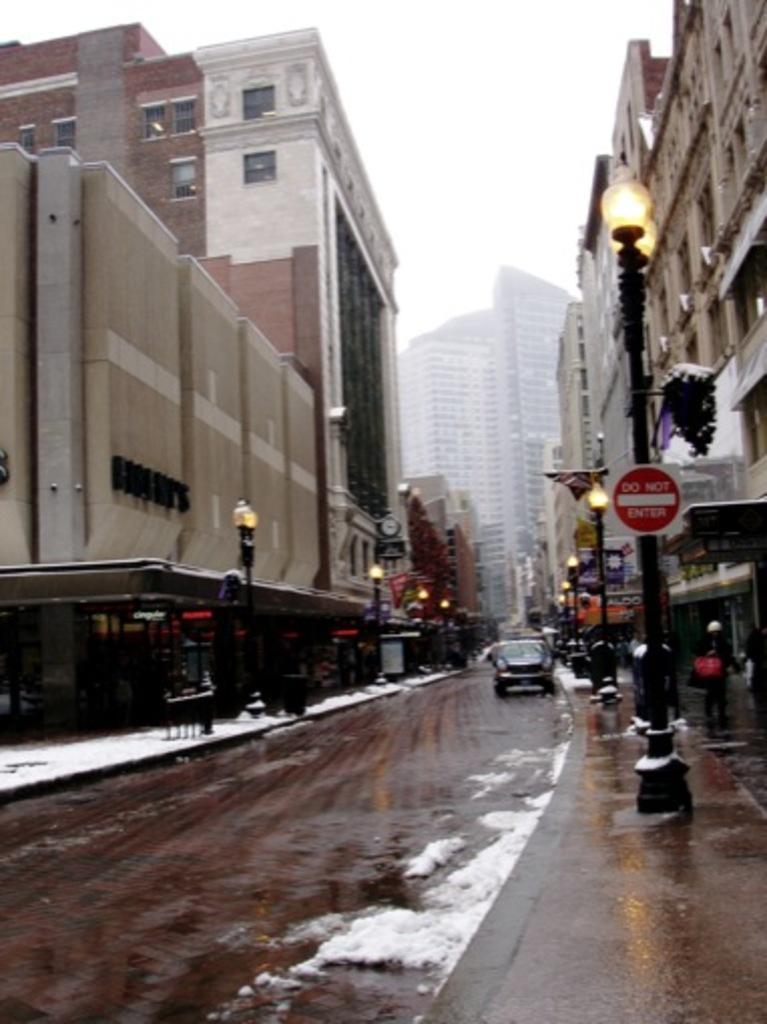Can you describe this image briefly? This is an outside view. Hear I can see the road, in some places I can see the snow. In the background there is a car. On both sides of the road I can see the poles and buildings. On the top of the image I can see the sky. 